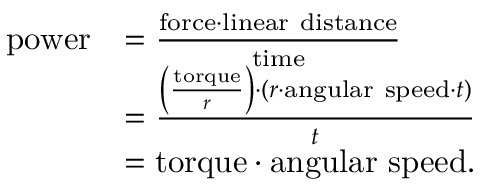Convert formula to latex. <formula><loc_0><loc_0><loc_500><loc_500>{ \begin{array} { r l } { p o w e r } & { = { \frac { { f o r c e } \cdot { l i n e a r d i s t a n c e } } { t i m e } } } \\ & { = { \frac { \left ( { \frac { t o r q u e } { r } } \right ) \cdot ( r \cdot { a n g u l a r s p e e d } \cdot t ) } { t } } } \\ & { = { t o r q u e } \cdot { a n g u l a r s p e e d } . } \end{array} }</formula> 